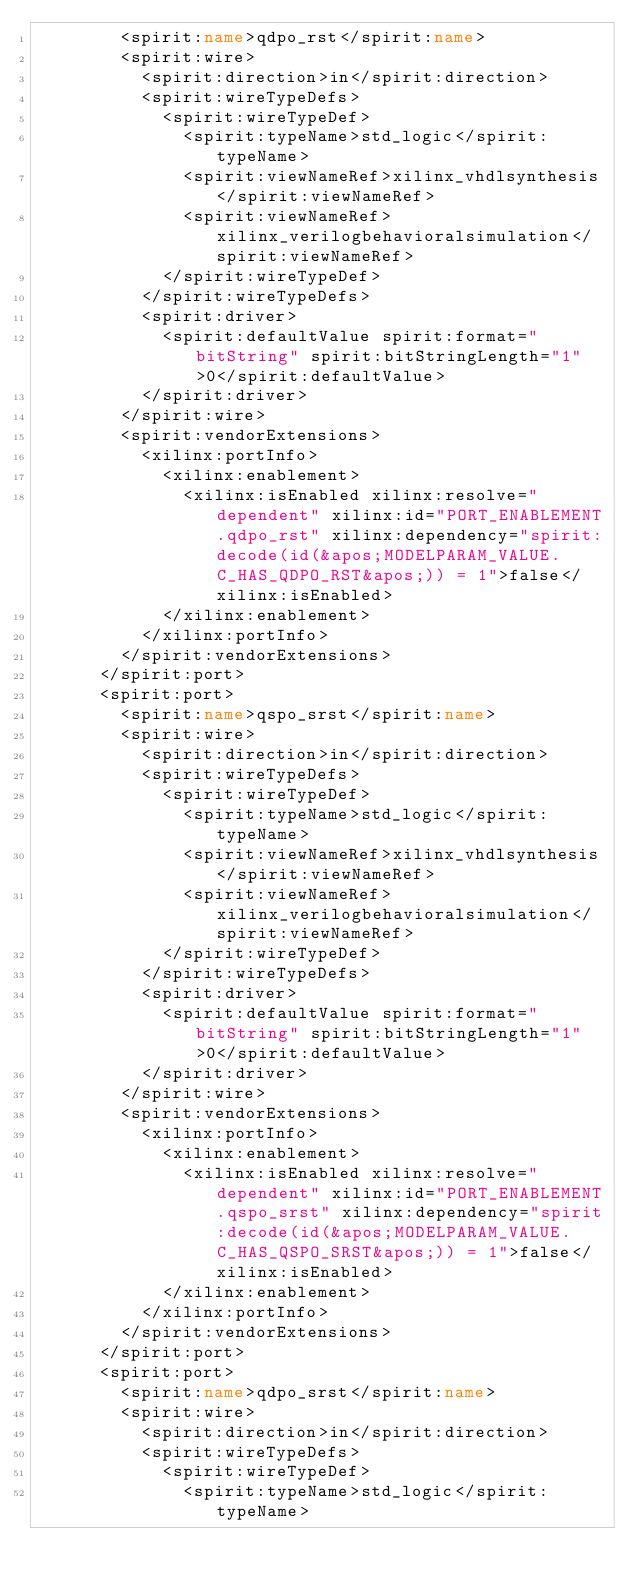Convert code to text. <code><loc_0><loc_0><loc_500><loc_500><_XML_>        <spirit:name>qdpo_rst</spirit:name>
        <spirit:wire>
          <spirit:direction>in</spirit:direction>
          <spirit:wireTypeDefs>
            <spirit:wireTypeDef>
              <spirit:typeName>std_logic</spirit:typeName>
              <spirit:viewNameRef>xilinx_vhdlsynthesis</spirit:viewNameRef>
              <spirit:viewNameRef>xilinx_verilogbehavioralsimulation</spirit:viewNameRef>
            </spirit:wireTypeDef>
          </spirit:wireTypeDefs>
          <spirit:driver>
            <spirit:defaultValue spirit:format="bitString" spirit:bitStringLength="1">0</spirit:defaultValue>
          </spirit:driver>
        </spirit:wire>
        <spirit:vendorExtensions>
          <xilinx:portInfo>
            <xilinx:enablement>
              <xilinx:isEnabled xilinx:resolve="dependent" xilinx:id="PORT_ENABLEMENT.qdpo_rst" xilinx:dependency="spirit:decode(id(&apos;MODELPARAM_VALUE.C_HAS_QDPO_RST&apos;)) = 1">false</xilinx:isEnabled>
            </xilinx:enablement>
          </xilinx:portInfo>
        </spirit:vendorExtensions>
      </spirit:port>
      <spirit:port>
        <spirit:name>qspo_srst</spirit:name>
        <spirit:wire>
          <spirit:direction>in</spirit:direction>
          <spirit:wireTypeDefs>
            <spirit:wireTypeDef>
              <spirit:typeName>std_logic</spirit:typeName>
              <spirit:viewNameRef>xilinx_vhdlsynthesis</spirit:viewNameRef>
              <spirit:viewNameRef>xilinx_verilogbehavioralsimulation</spirit:viewNameRef>
            </spirit:wireTypeDef>
          </spirit:wireTypeDefs>
          <spirit:driver>
            <spirit:defaultValue spirit:format="bitString" spirit:bitStringLength="1">0</spirit:defaultValue>
          </spirit:driver>
        </spirit:wire>
        <spirit:vendorExtensions>
          <xilinx:portInfo>
            <xilinx:enablement>
              <xilinx:isEnabled xilinx:resolve="dependent" xilinx:id="PORT_ENABLEMENT.qspo_srst" xilinx:dependency="spirit:decode(id(&apos;MODELPARAM_VALUE.C_HAS_QSPO_SRST&apos;)) = 1">false</xilinx:isEnabled>
            </xilinx:enablement>
          </xilinx:portInfo>
        </spirit:vendorExtensions>
      </spirit:port>
      <spirit:port>
        <spirit:name>qdpo_srst</spirit:name>
        <spirit:wire>
          <spirit:direction>in</spirit:direction>
          <spirit:wireTypeDefs>
            <spirit:wireTypeDef>
              <spirit:typeName>std_logic</spirit:typeName></code> 